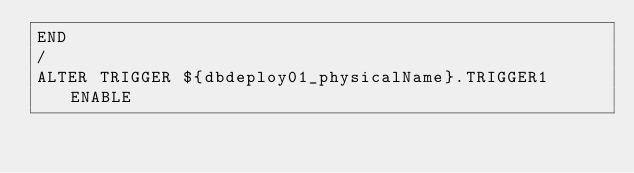Convert code to text. <code><loc_0><loc_0><loc_500><loc_500><_SQL_>END
/
ALTER TRIGGER ${dbdeploy01_physicalName}.TRIGGER1 ENABLE
</code> 